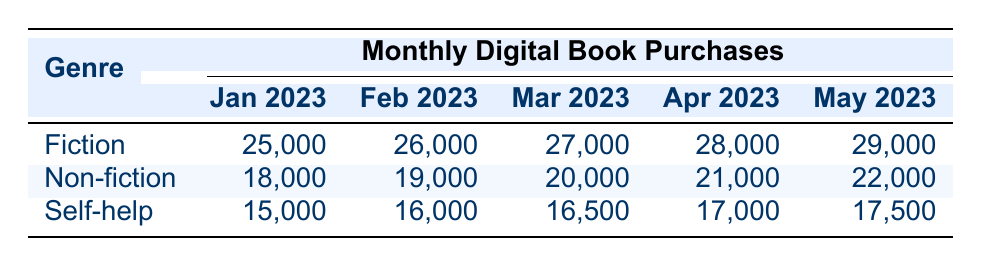What was the highest number of digital book purchases in February 2023? In February 2023, Fiction had 26,000 purchases, Non-fiction had 19,000 purchases, and Self-help had 16,000 purchases. The highest number among these genres is 26,000 for Fiction.
Answer: 26,000 Which genre saw the greatest increase in purchases from January to May 2023? For each genre: Fiction increased from 25,000 to 29,000 (4,000 more), Non-fiction increased from 18,000 to 22,000 (4,000 more), and Self-help increased from 15,000 to 17,500 (2,500 more). Both Fiction and Non-fiction had the greatest increase at 4,000.
Answer: Fiction and Non-fiction What is the total number of digital book purchases for Self-help in March 2023? In March 2023, Self-help had 16,500 purchases. Therefore, the total number for Self-help in March 2023 is simply 16,500.
Answer: 16,500 Is it true that Non-fiction purchases were consistently lower than Fiction purchases for all months? Comparing the purchases: In January, Non-fiction (18,000) was lower than Fiction (25,000); February: Non-fiction (19,000) was lower than Fiction (26,000); March: Non-fiction (20,000) was lower than Fiction (27,000); April: Non-fiction (21,000) was lower than Fiction (28,000); May: Non-fiction (22,000) was lower than Fiction (29,000). The statement is true.
Answer: Yes What was the average number of purchases for Fiction across the five months? To find the average, sum the Fiction purchases from January to May: 25,000 + 26,000 + 27,000 + 28,000 + 29,000 = 135,000. Then, divide by 5 (the number of months): 135,000 / 5 = 27,000.
Answer: 27,000 